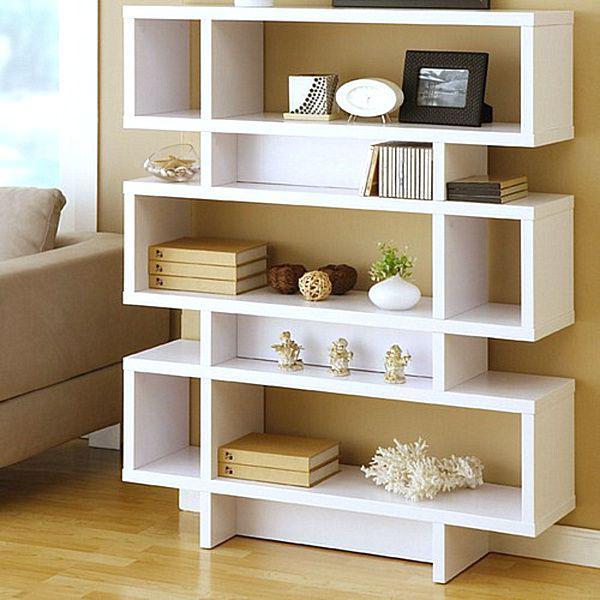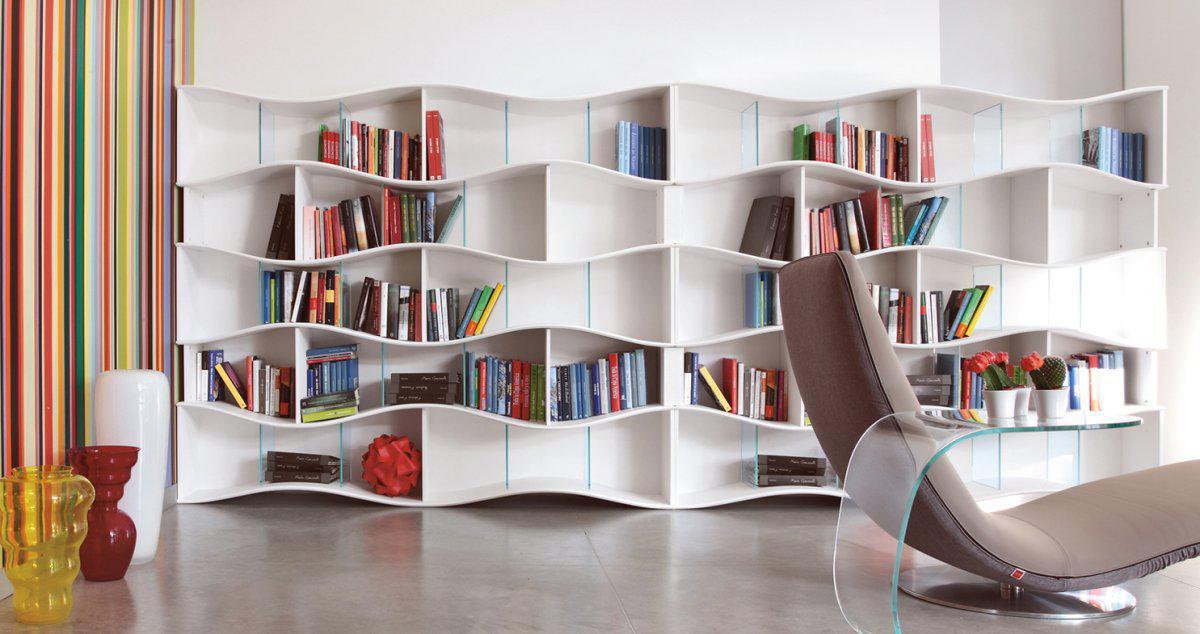The first image is the image on the left, the second image is the image on the right. Analyze the images presented: Is the assertion "The left image shows an all white bookcase with an open back." valid? Answer yes or no. Yes. 